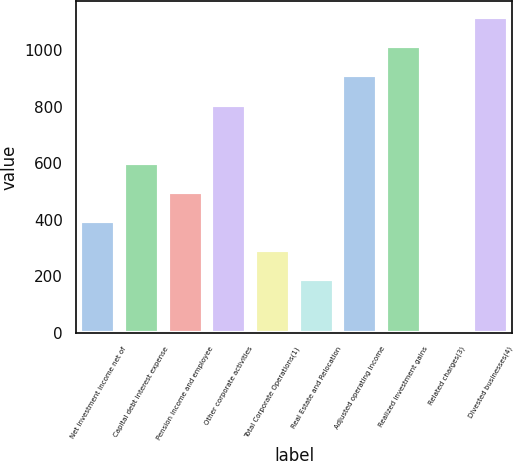Convert chart. <chart><loc_0><loc_0><loc_500><loc_500><bar_chart><fcel>Net investment income net of<fcel>Capital debt interest expense<fcel>Pension income and employee<fcel>Other corporate activities<fcel>Total Corporate Operations(1)<fcel>Real Estate and Relocation<fcel>Adjusted operating income<fcel>Realized investment gains<fcel>Related charges(3)<fcel>Divested businesses(4)<nl><fcel>395.2<fcel>601.4<fcel>498.3<fcel>807.6<fcel>292.1<fcel>189<fcel>910.7<fcel>1013.8<fcel>4<fcel>1116.9<nl></chart> 